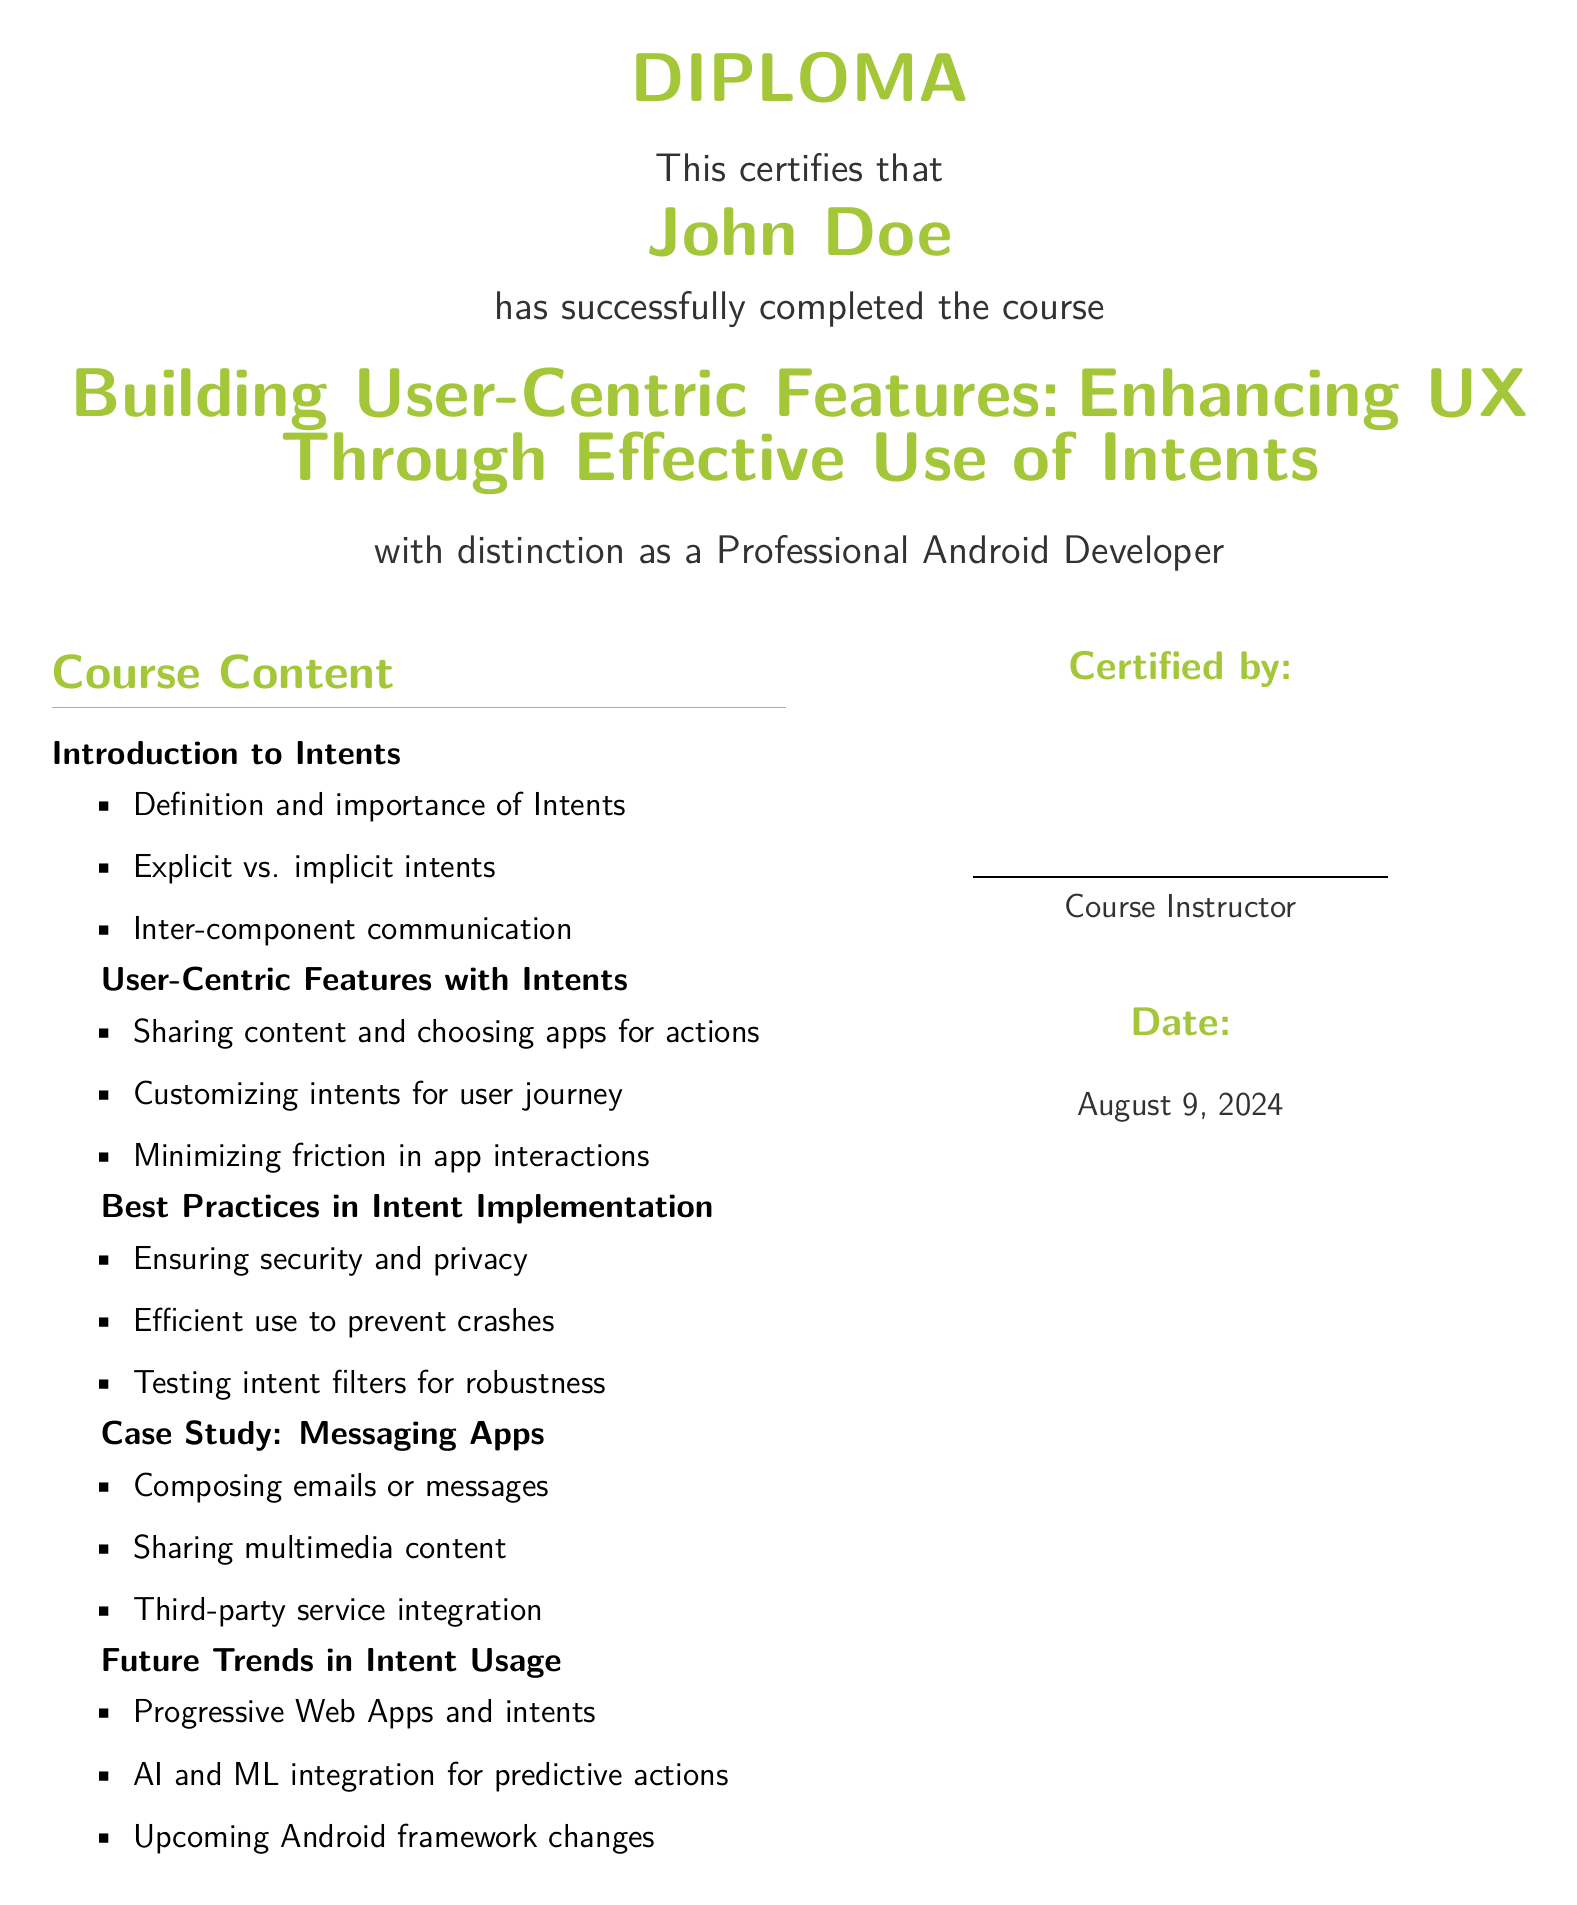What is the name of the certificate holder? The document certifies John Doe has completed the course.
Answer: John Doe What is the title of the course? The course title is prominently displayed on the diploma.
Answer: Building User-Centric Features: Enhancing UX Through Effective Use of Intents Who is the course instructor? The instructor's name is represented by a line for signature but is noted as "Course Instructor."
Answer: Course Instructor What is the primary focus of the course? The course focuses on effective use of intents to enhance UX, as suggested in the title.
Answer: Enhancing UX Through Effective Use of Intents What section discusses best practices? The document contains a section specifically addressing best practices related to intent implementation.
Answer: Best Practices in Intent Implementation What is included in the case study? The case study section of the document outlines specific functions related to messaging apps.
Answer: Messaging Apps What color is used for the diploma's title? The diploma title is highlighted in a specific color that is distinct in the design.
Answer: Android Green On what date was the diploma issued? The diploma includes a date that is automatically generated at the time of printing.
Answer: Today 